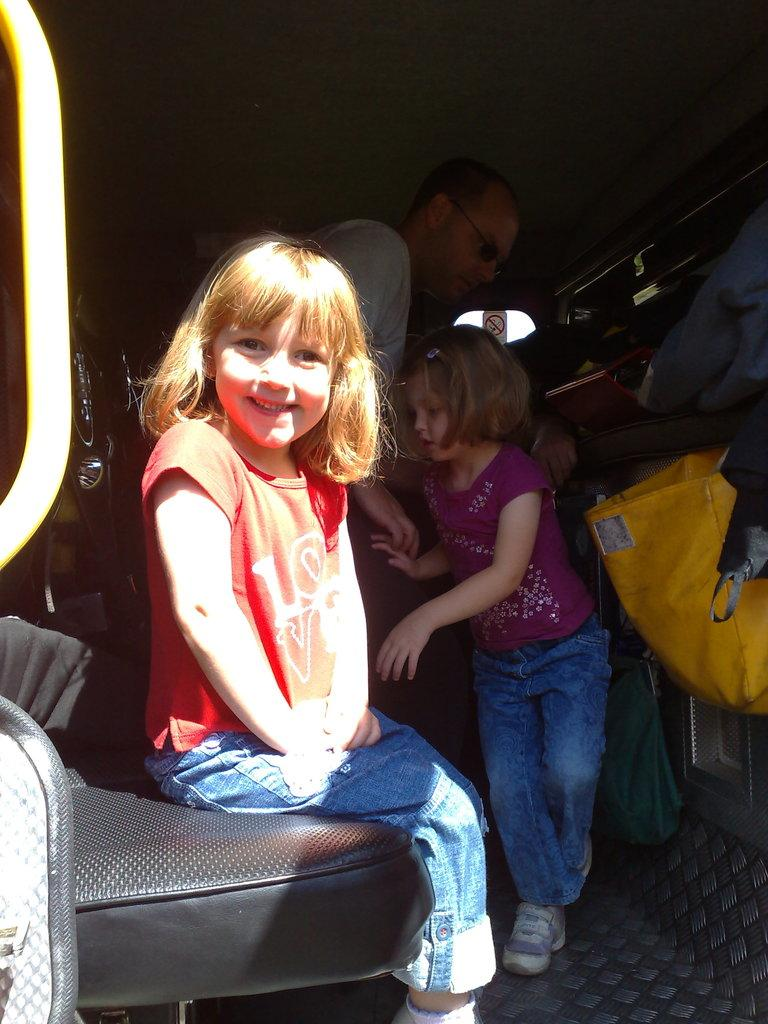What are the people in the image doing? There are people standing on the floor and sitting on a sofa in the image. Can you describe the objects in the background of the image? There are cloth bags and a sign board in the background of the image. What type of attraction is being performed by the band in the image? There is no attraction or band present in the image. 